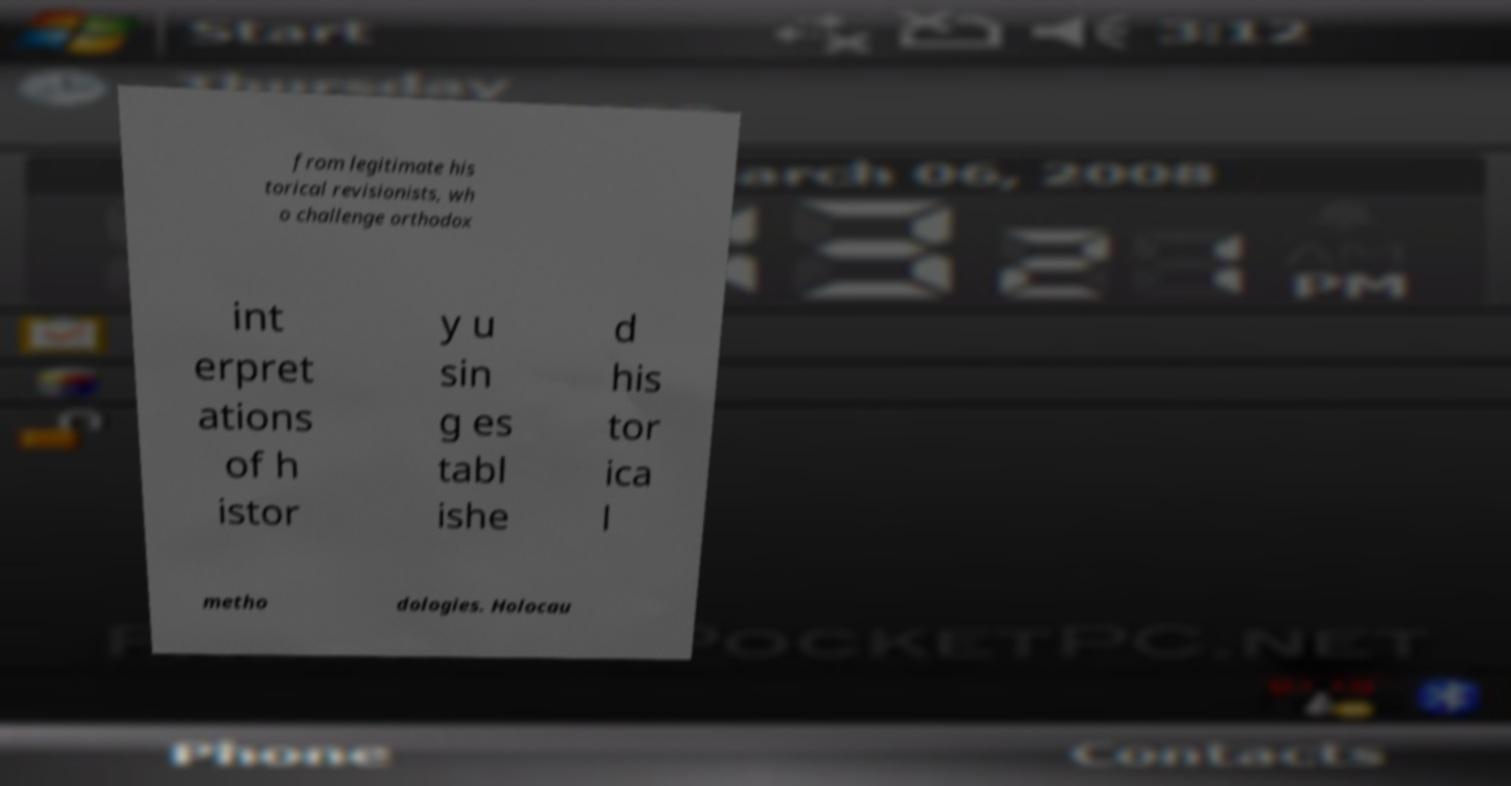Please identify and transcribe the text found in this image. from legitimate his torical revisionists, wh o challenge orthodox int erpret ations of h istor y u sin g es tabl ishe d his tor ica l metho dologies. Holocau 